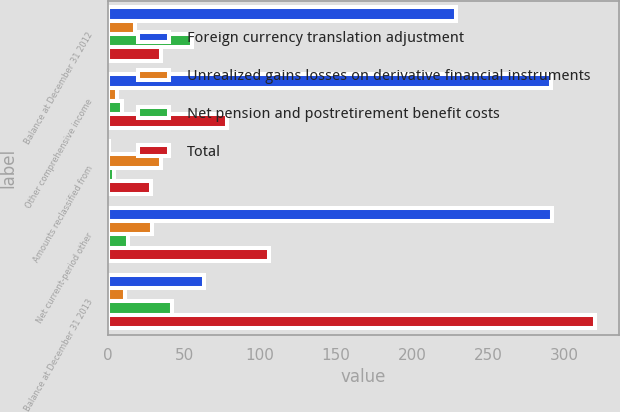Convert chart to OTSL. <chart><loc_0><loc_0><loc_500><loc_500><stacked_bar_chart><ecel><fcel>Balance at December 31 2012<fcel>Other comprehensive income<fcel>Amounts reclassified from<fcel>Net current-period other<fcel>Balance at December 31 2013<nl><fcel>Foreign currency translation adjustment<fcel>229<fcel>291<fcel>1<fcel>292<fcel>63<nl><fcel>Unrealized gains losses on derivative financial instruments<fcel>18<fcel>6<fcel>35<fcel>29<fcel>11<nl><fcel>Net pension and postretirement benefit costs<fcel>55<fcel>9<fcel>4<fcel>13<fcel>42<nl><fcel>Total<fcel>35<fcel>78<fcel>28<fcel>106<fcel>320<nl></chart> 